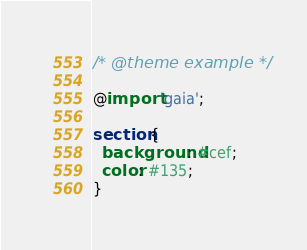Convert code to text. <code><loc_0><loc_0><loc_500><loc_500><_CSS_>/* @theme example */

@import 'gaia';

section {
  background: #cef;
  color: #135;
}
</code> 